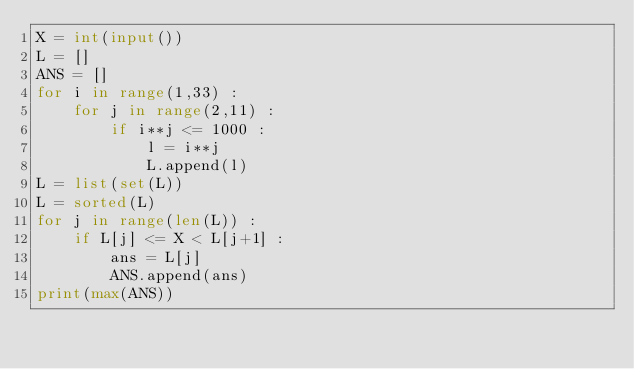<code> <loc_0><loc_0><loc_500><loc_500><_Python_>X = int(input())
L = []
ANS = []
for i in range(1,33) :
    for j in range(2,11) :
        if i**j <= 1000 :
            l = i**j
            L.append(l)
L = list(set(L))
L = sorted(L)
for j in range(len(L)) :
    if L[j] <= X < L[j+1] :
        ans = L[j]
        ANS.append(ans)
print(max(ANS))

</code> 